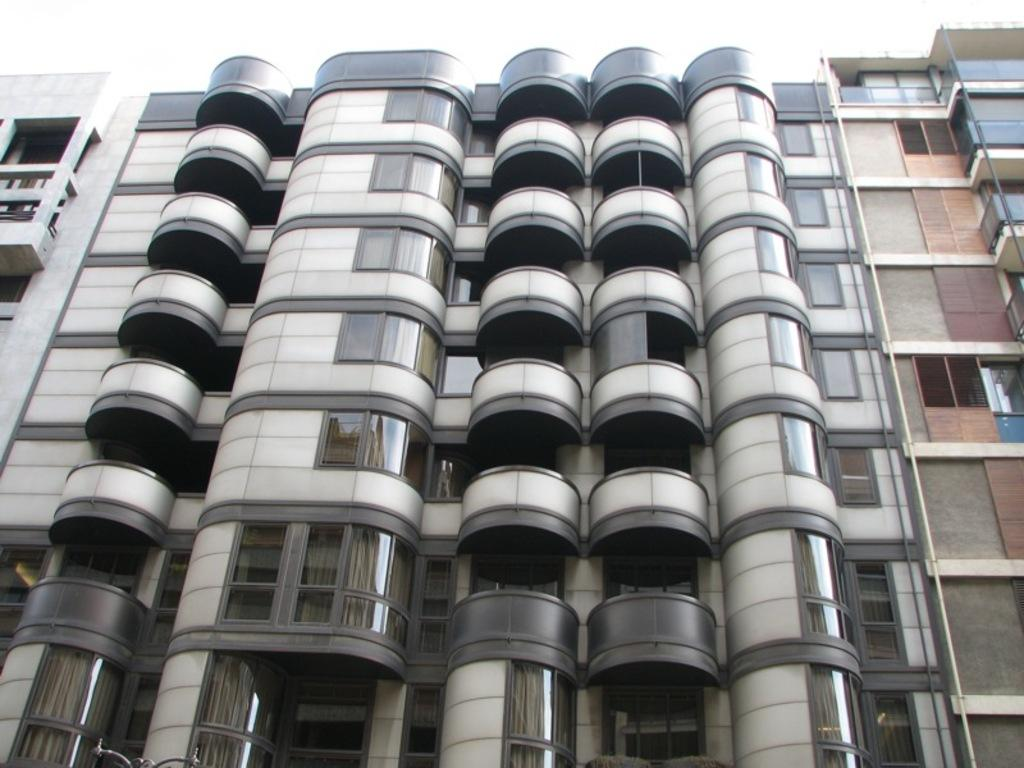What type of structure is present in the image? There is a building in the image. What architectural features can be seen on the building? The building has balconies and glass walls. Are there any openings in the building? Yes, the building has windows. What is visible at the top of the image? The sky is visible at the top of the image. What type of cannon is mounted on the building in the image? There is no cannon present on the building in the image. What material is the steel screw used to construct the building made of? There is no mention of steel screws being used in the construction of the building in the image. 